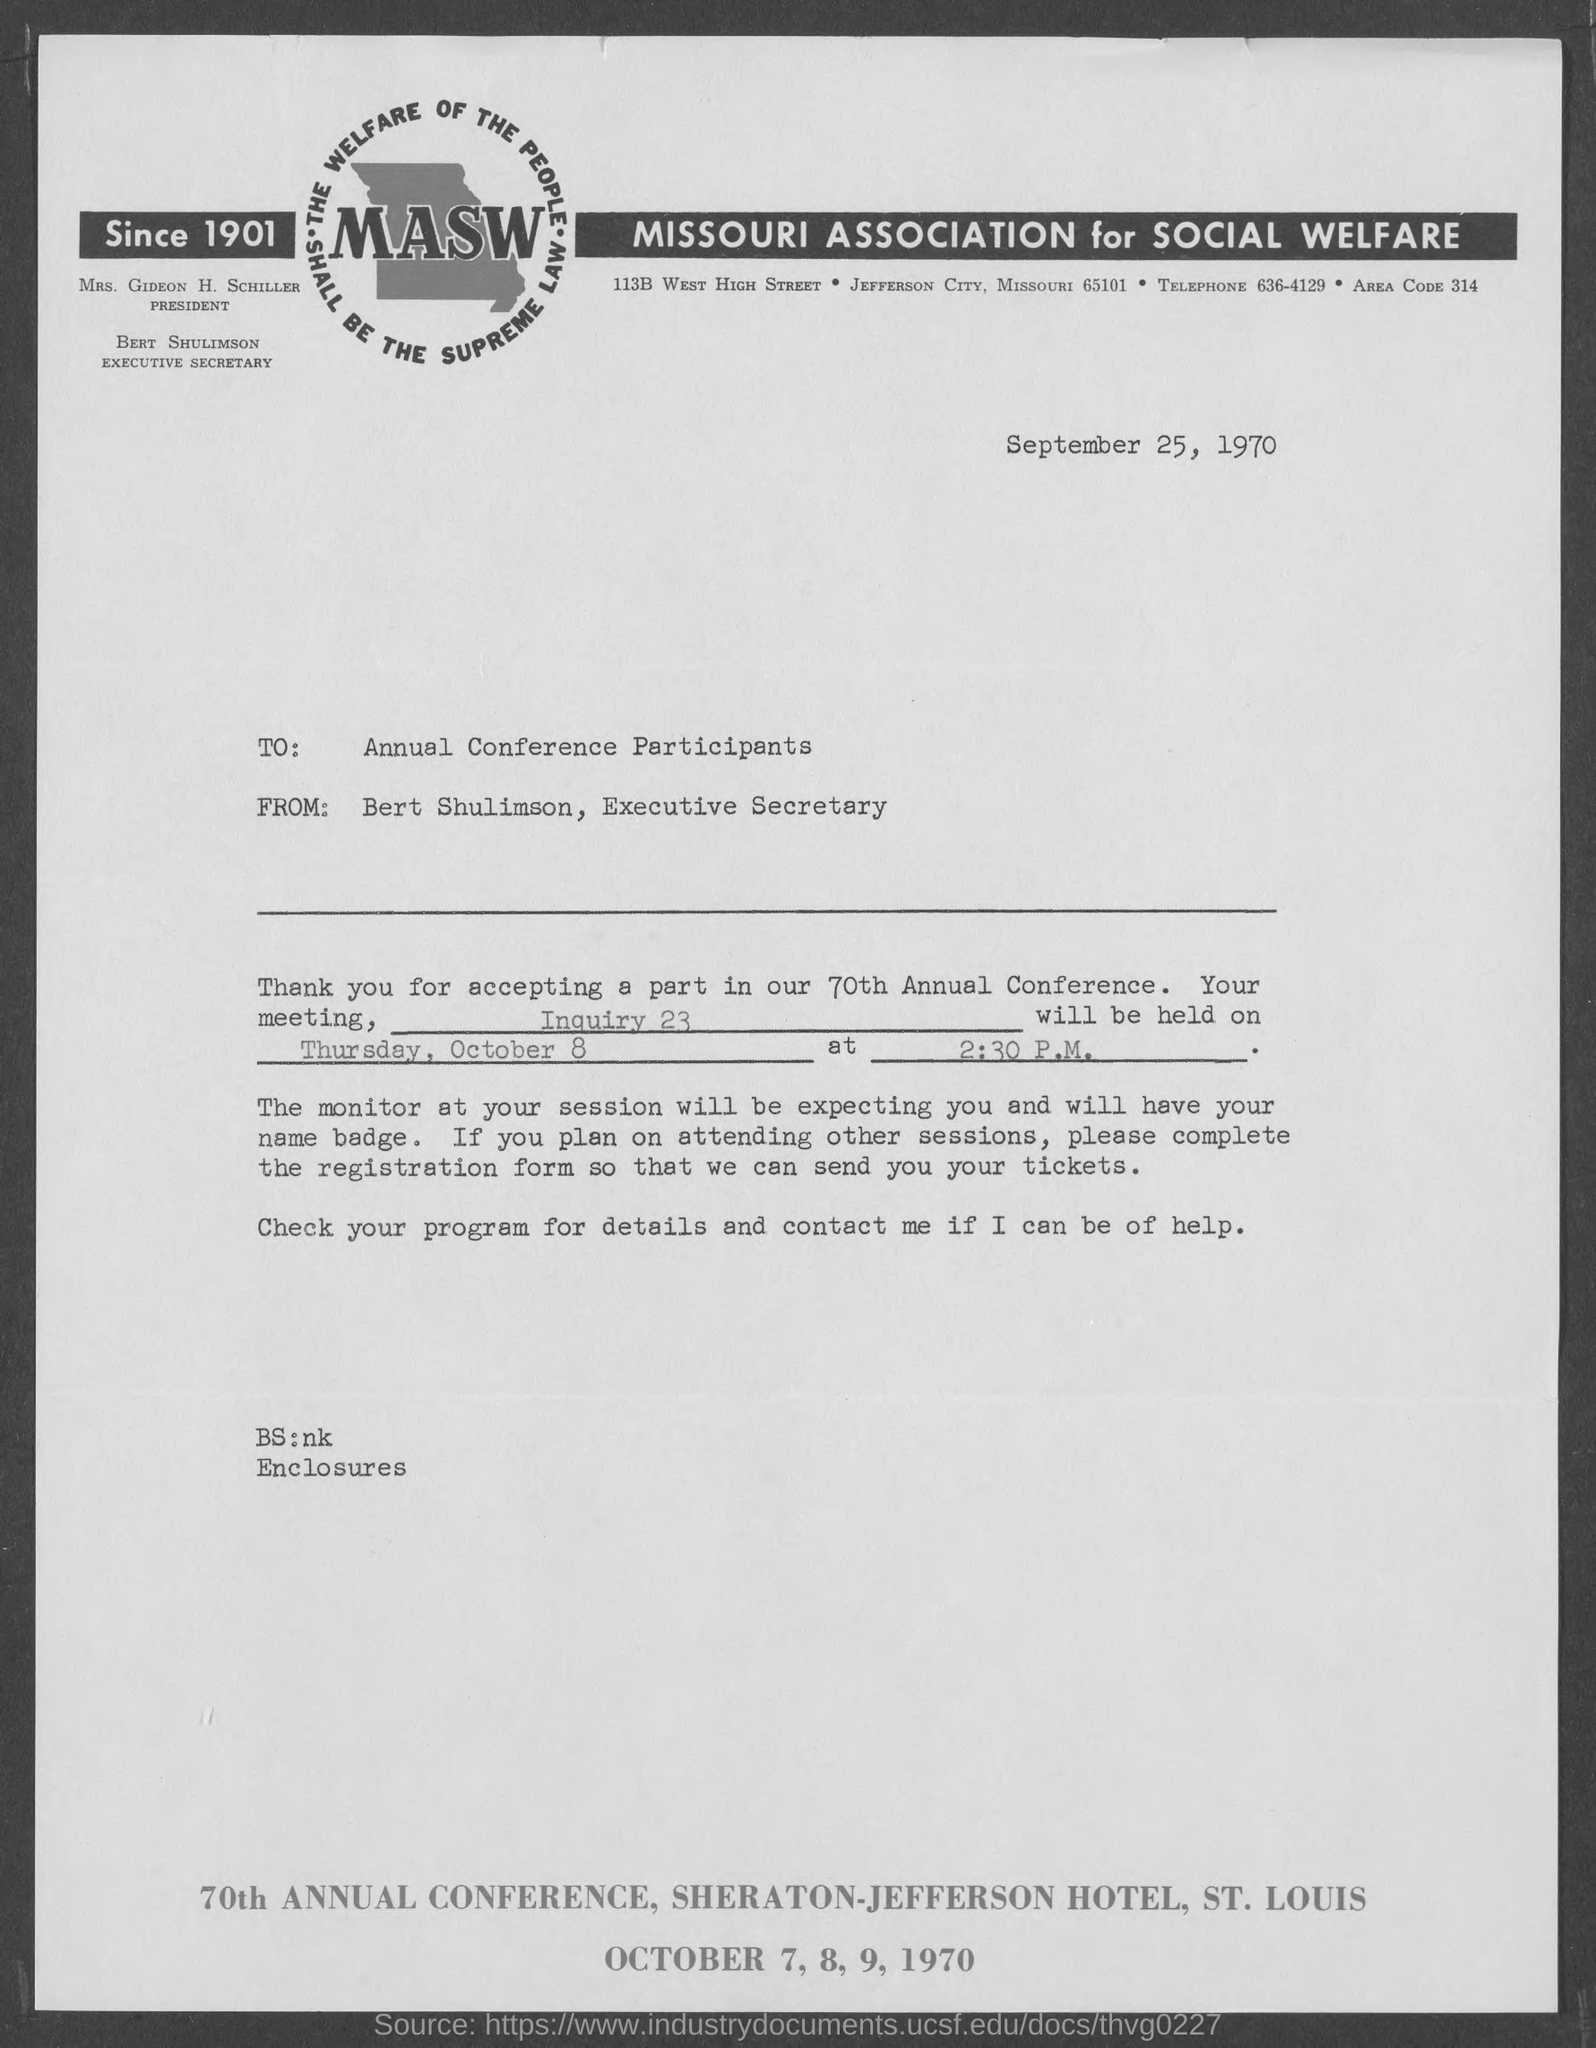What is the Fullform of MASW ?
Your response must be concise. Missouri Association for Social Welfare. Who is the Executive Secretary ?
Your response must be concise. Bert Shulimson. What is the date mentioned in the top of the document ?
Offer a very short reply. September 25, 1970. 